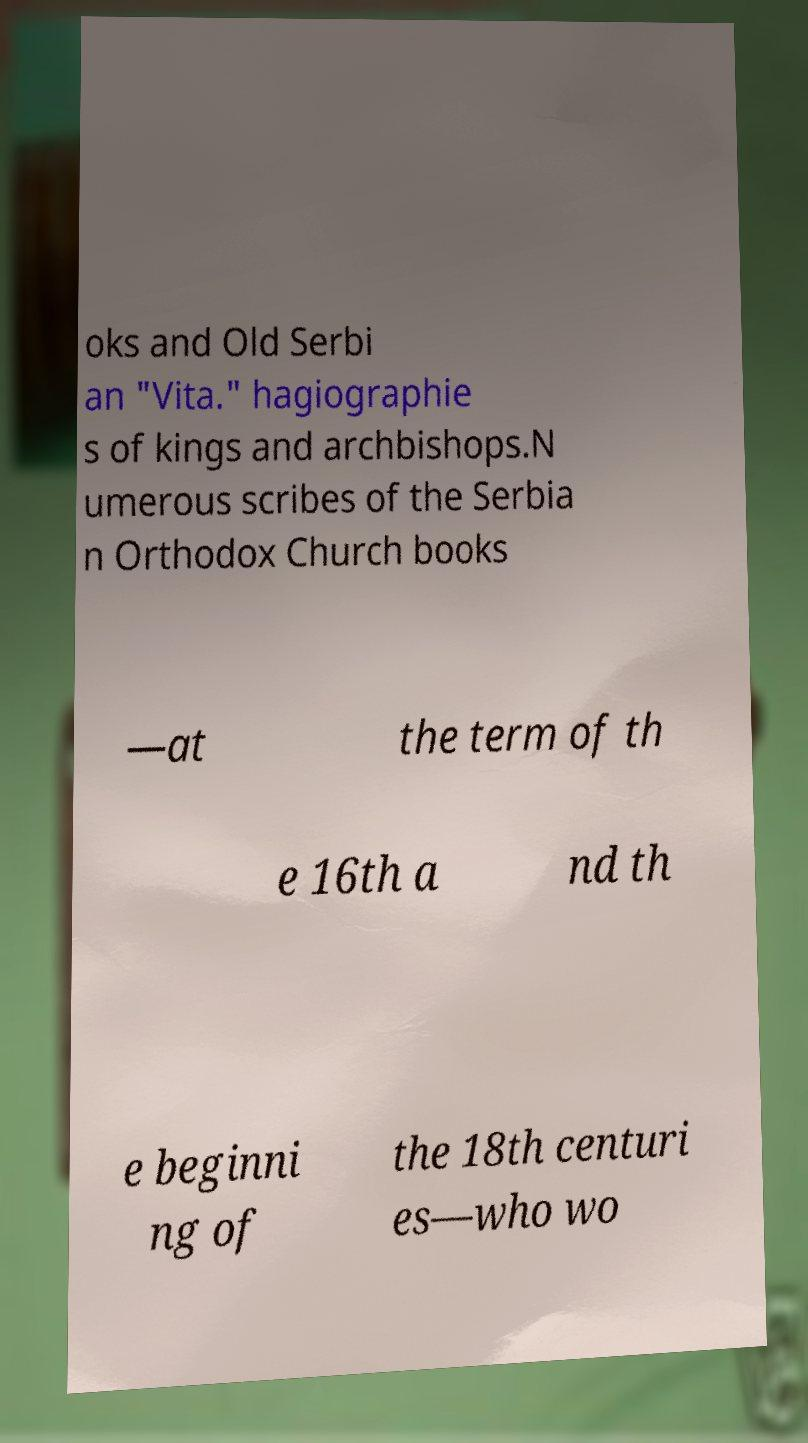What messages or text are displayed in this image? I need them in a readable, typed format. oks and Old Serbi an "Vita." hagiographie s of kings and archbishops.N umerous scribes of the Serbia n Orthodox Church books —at the term of th e 16th a nd th e beginni ng of the 18th centuri es—who wo 